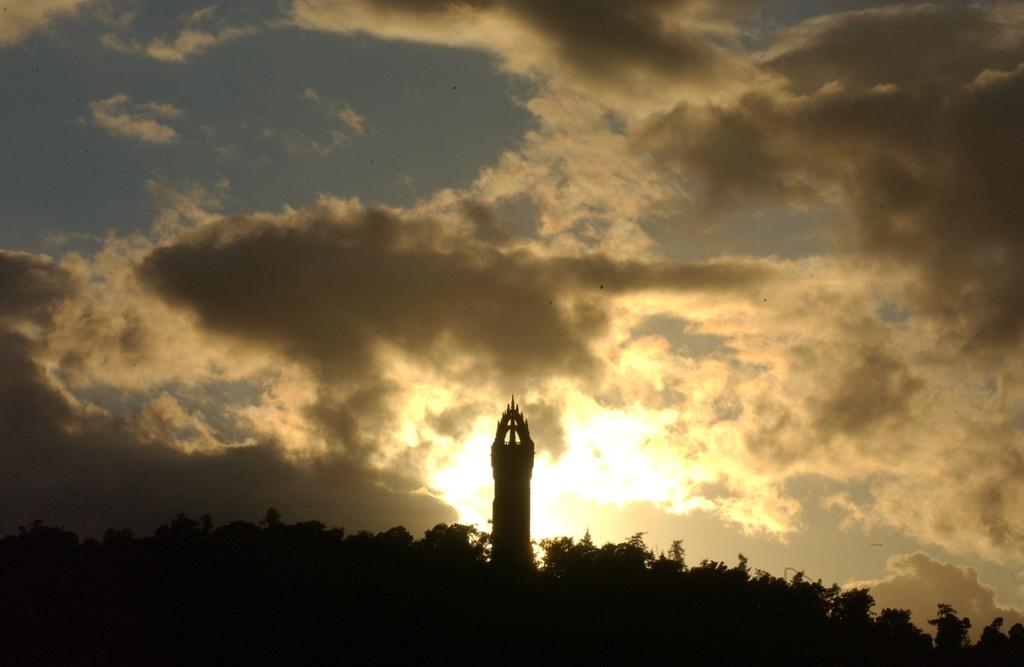What is the main structure visible in the image? There is a tower in the image. Where is the tower located in relation to the trees? The tower is situated between trees. What can be seen in the sky in the image? There are clouds visible in the sky. What part of the natural environment is visible in the image? The sky is visible in the image. Can you tell me how many people are involved in the fight depicted in the image? There is no fight depicted in the image; it features a tower situated between trees. How many partners are visible in the image? There are no partners present in the image. 